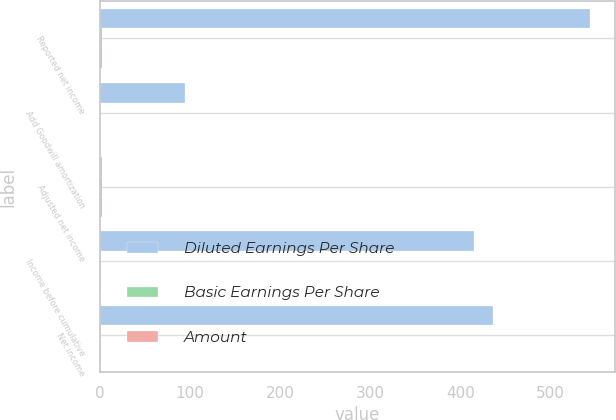Convert chart to OTSL. <chart><loc_0><loc_0><loc_500><loc_500><stacked_bar_chart><ecel><fcel>Reported net income<fcel>Add Goodwill amortization<fcel>Adjusted net income<fcel>Income before cumulative<fcel>Net income<nl><fcel>Diluted Earnings Per Share<fcel>544<fcel>95<fcel>2.16<fcel>415<fcel>436<nl><fcel>Basic Earnings Per Share<fcel>2.17<fcel>0.38<fcel>2.55<fcel>1.76<fcel>1.85<nl><fcel>Amount<fcel>2.15<fcel>0.38<fcel>2.53<fcel>1.76<fcel>1.85<nl></chart> 